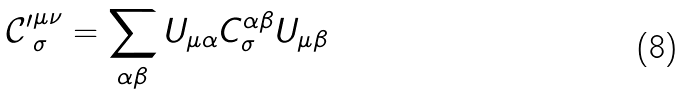<formula> <loc_0><loc_0><loc_500><loc_500>\mathcal { C ^ { \prime } } _ { \sigma } ^ { \mu \nu } = \sum _ { \alpha \beta } U _ { \mu \alpha } C _ { \sigma } ^ { \alpha \beta } U _ { \mu \beta }</formula> 